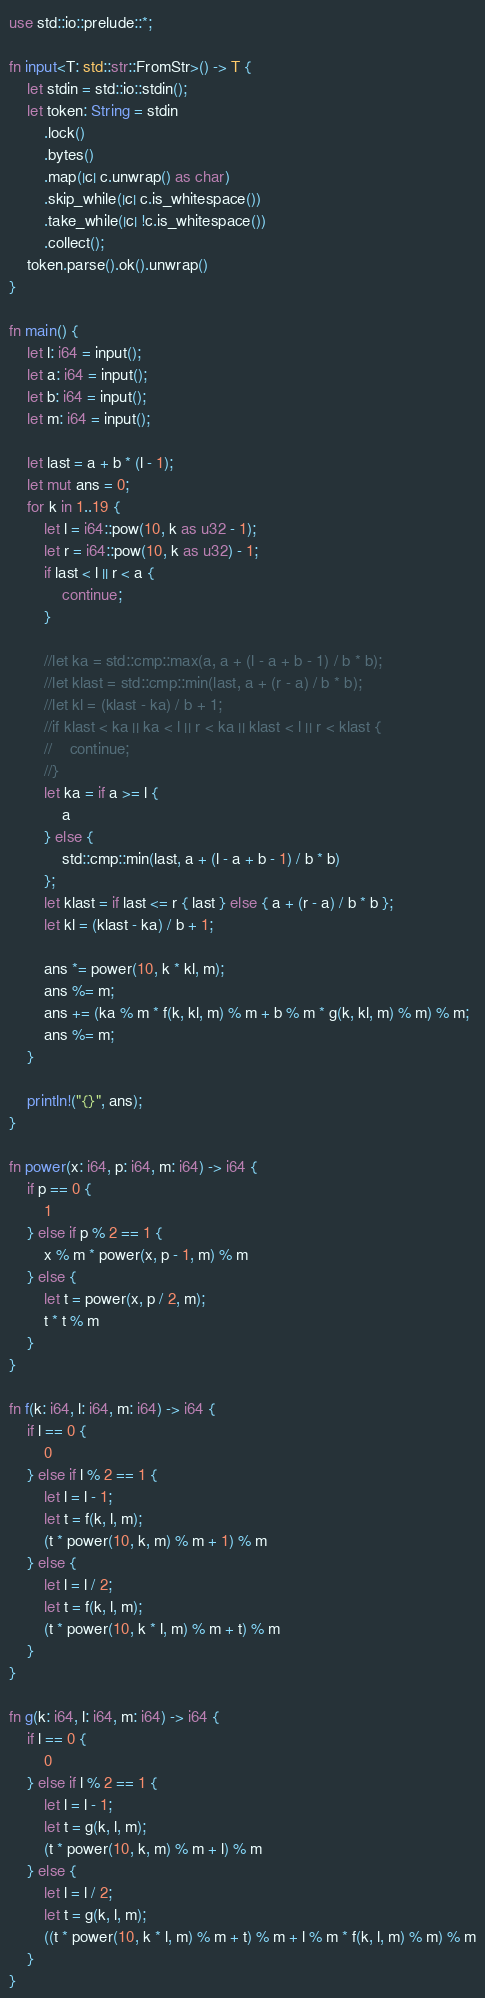Convert code to text. <code><loc_0><loc_0><loc_500><loc_500><_Rust_>use std::io::prelude::*;

fn input<T: std::str::FromStr>() -> T {
    let stdin = std::io::stdin();
    let token: String = stdin
        .lock()
        .bytes()
        .map(|c| c.unwrap() as char)
        .skip_while(|c| c.is_whitespace())
        .take_while(|c| !c.is_whitespace())
        .collect();
    token.parse().ok().unwrap()
}

fn main() {
    let l: i64 = input();
    let a: i64 = input();
    let b: i64 = input();
    let m: i64 = input();

    let last = a + b * (l - 1);
    let mut ans = 0;
    for k in 1..19 {
        let l = i64::pow(10, k as u32 - 1);
        let r = i64::pow(10, k as u32) - 1;
        if last < l || r < a {
            continue;
        }

        //let ka = std::cmp::max(a, a + (l - a + b - 1) / b * b);
        //let klast = std::cmp::min(last, a + (r - a) / b * b);
        //let kl = (klast - ka) / b + 1;
        //if klast < ka || ka < l || r < ka || klast < l || r < klast {
        //    continue;
        //}
        let ka = if a >= l {
            a
        } else {
            std::cmp::min(last, a + (l - a + b - 1) / b * b)
        };
        let klast = if last <= r { last } else { a + (r - a) / b * b };
        let kl = (klast - ka) / b + 1;

        ans *= power(10, k * kl, m);
        ans %= m;
        ans += (ka % m * f(k, kl, m) % m + b % m * g(k, kl, m) % m) % m;
        ans %= m;
    }

    println!("{}", ans);
}

fn power(x: i64, p: i64, m: i64) -> i64 {
    if p == 0 {
        1
    } else if p % 2 == 1 {
        x % m * power(x, p - 1, m) % m
    } else {
        let t = power(x, p / 2, m);
        t * t % m
    }
}

fn f(k: i64, l: i64, m: i64) -> i64 {
    if l == 0 {
        0
    } else if l % 2 == 1 {
        let l = l - 1;
        let t = f(k, l, m);
        (t * power(10, k, m) % m + 1) % m
    } else {
        let l = l / 2;
        let t = f(k, l, m);
        (t * power(10, k * l, m) % m + t) % m
    }
}

fn g(k: i64, l: i64, m: i64) -> i64 {
    if l == 0 {
        0
    } else if l % 2 == 1 {
        let l = l - 1;
        let t = g(k, l, m);
        (t * power(10, k, m) % m + l) % m
    } else {
        let l = l / 2;
        let t = g(k, l, m);
        ((t * power(10, k * l, m) % m + t) % m + l % m * f(k, l, m) % m) % m
    }
}
</code> 